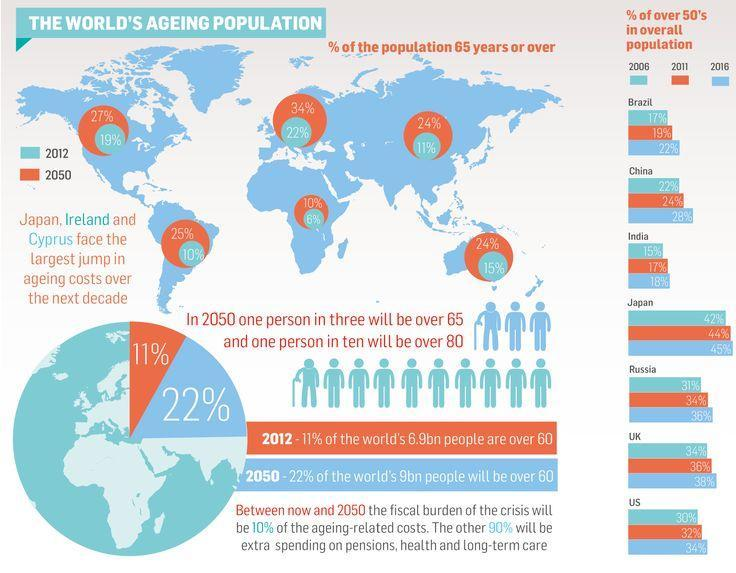Which continent has 19% population of people above age 65 in 2012 - Australia, Europe or North America?
Answer the question with a short phrase. North America In which continent the population of senior citizens will be 34% in 2050 - Asia, Europe or Africa? Europe What is the expected population % of senior citizens in Australia in 2050? 24% What will be the percent of population of people over 65 in South America in 2050? 25% 